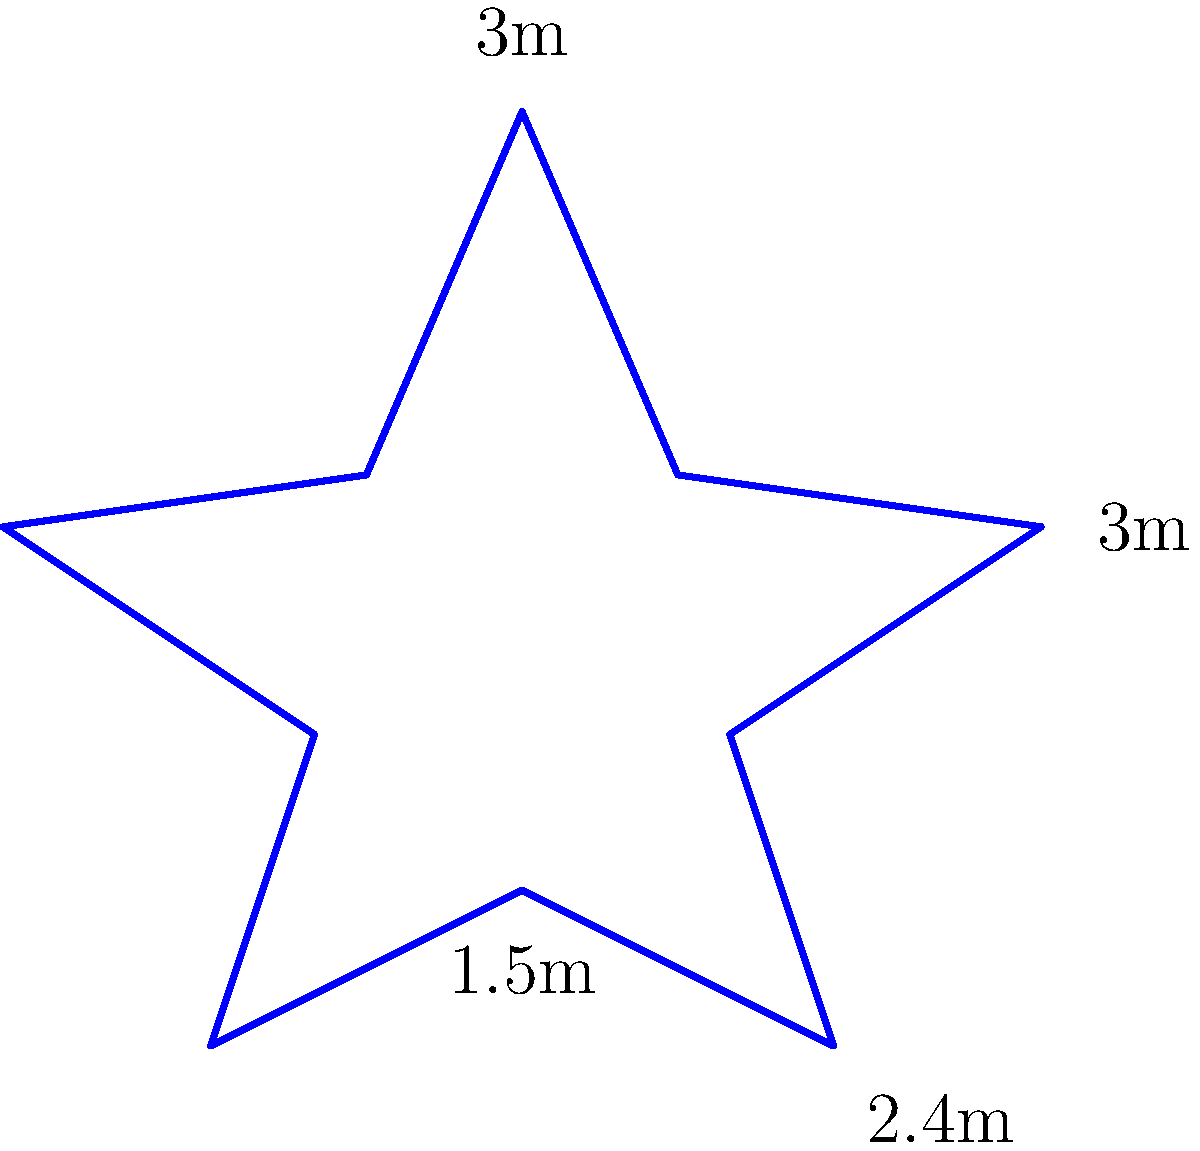As a child actor, you're on a set for a new sci-fi movie. The director wants to create a star-shaped platform for a key scene. The set designer shows you this diagram of the platform. If each side of the star has a length of 2 meters, what is the perimeter of the entire star-shaped platform? Let's approach this step-by-step:

1) First, we need to understand what the perimeter means. The perimeter is the total distance around the outside of a shape.

2) In this case, we're dealing with a star shape. A star has 10 sides.

3) We're told that each side of the star has a length of 2 meters.

4) To find the perimeter, we need to add up the lengths of all sides.

5) Since there are 10 sides, and each side is 2 meters long, we can calculate the perimeter as follows:

   $$ \text{Perimeter} = 10 \times 2\text{ meters} $$

6) Let's do the multiplication:

   $$ \text{Perimeter} = 20\text{ meters} $$

Therefore, the perimeter of the star-shaped platform is 20 meters.
Answer: 20 meters 